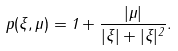Convert formula to latex. <formula><loc_0><loc_0><loc_500><loc_500>p ( \xi , \mu ) = 1 + \frac { | \mu | } { | \xi | + | \xi | ^ { 2 } } .</formula> 